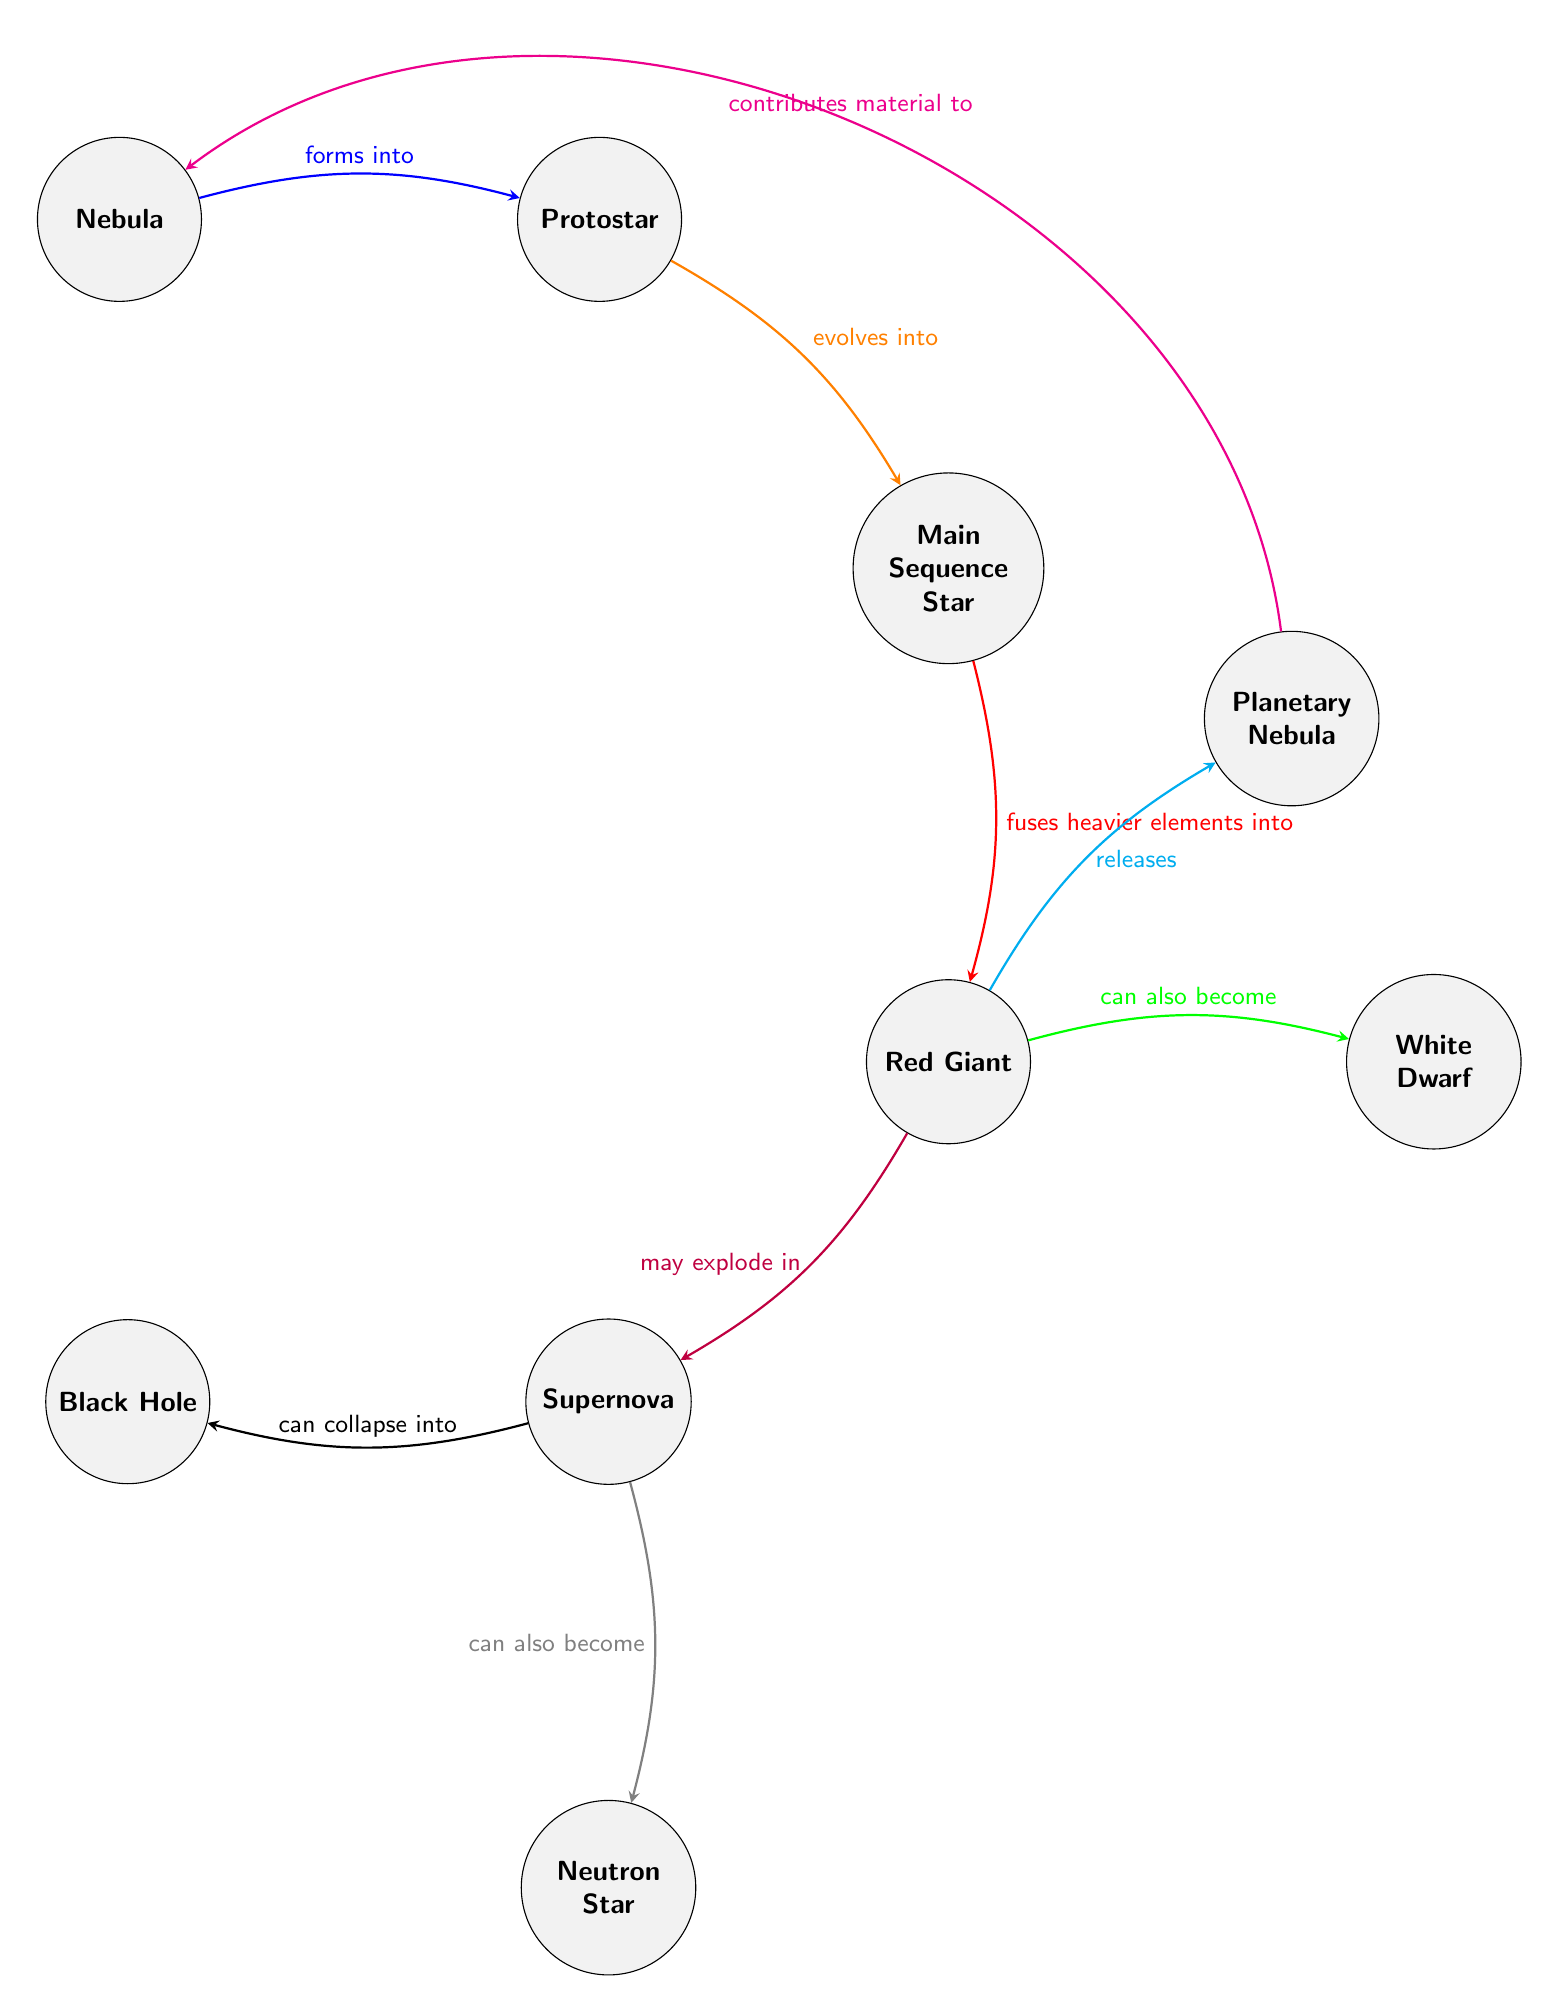What is the first stage in the star lifecycle? The diagram indicates that the first stage in the star lifecycle is represented by the node labeled "Nebula." This is the starting point for the formation of a star.
Answer: Nebula What stage directly evolves from the Protostar? According to the diagram, the stage that directly evolves from the Protostar is labeled "Main Sequence Star." This is shown by the arrow connecting Protostar to Main Sequence Star.
Answer: Main Sequence Star What can a Red Giant become after its lifecycle? The diagram illustrates that a Red Giant can evolve into a White Dwarf, which is connected by an arrow indicating this possible transformation.
Answer: White Dwarf How many end states are indicated for a Supernova? The diagram shows that a Supernova can collapse into either a Black Hole or a Neutron Star, indicating there are two possible end states, as represented by the two arrows leading away from the Supernova node.
Answer: 2 What contributes material back to the Nebula? The diagram specifies that a Planetary Nebula contributes material to the Nebula, which is shown by the curved arrow leading from the Planetary Nebula back to the Nebula.
Answer: Planetary Nebula What process occurs when a Main Sequence Star fuses elements? The diagram illustrates that a Main Sequence Star fuses heavier elements into a Red Giant, as indicated by the directed edge connecting these two nodes.
Answer: fuses heavier elements into What is a significant event that may happen to a Red Giant? The diagram indicates that a significant event that may happen to a Red Giant is that it may explode in a Supernova, as shown by the directed arrow leading from Red Giant to Supernova.
Answer: explode in What happens to a Protostar in its development stage? The diagram indicates that a Protostar evolves into a Main Sequence Star, which is depicted by the arrow connecting these two stages in the lifecycle.
Answer: evolves into How does a Supernova affect the lifecycle of stars? The diagram expresses that a Supernova can lead to different outcomes: it can collapse into a Black Hole or become a Neutron Star. These options depict how a Supernova impacts the lifecycle of stars by branching into different end states.
Answer: collapse into a Black Hole or become a Neutron Star 